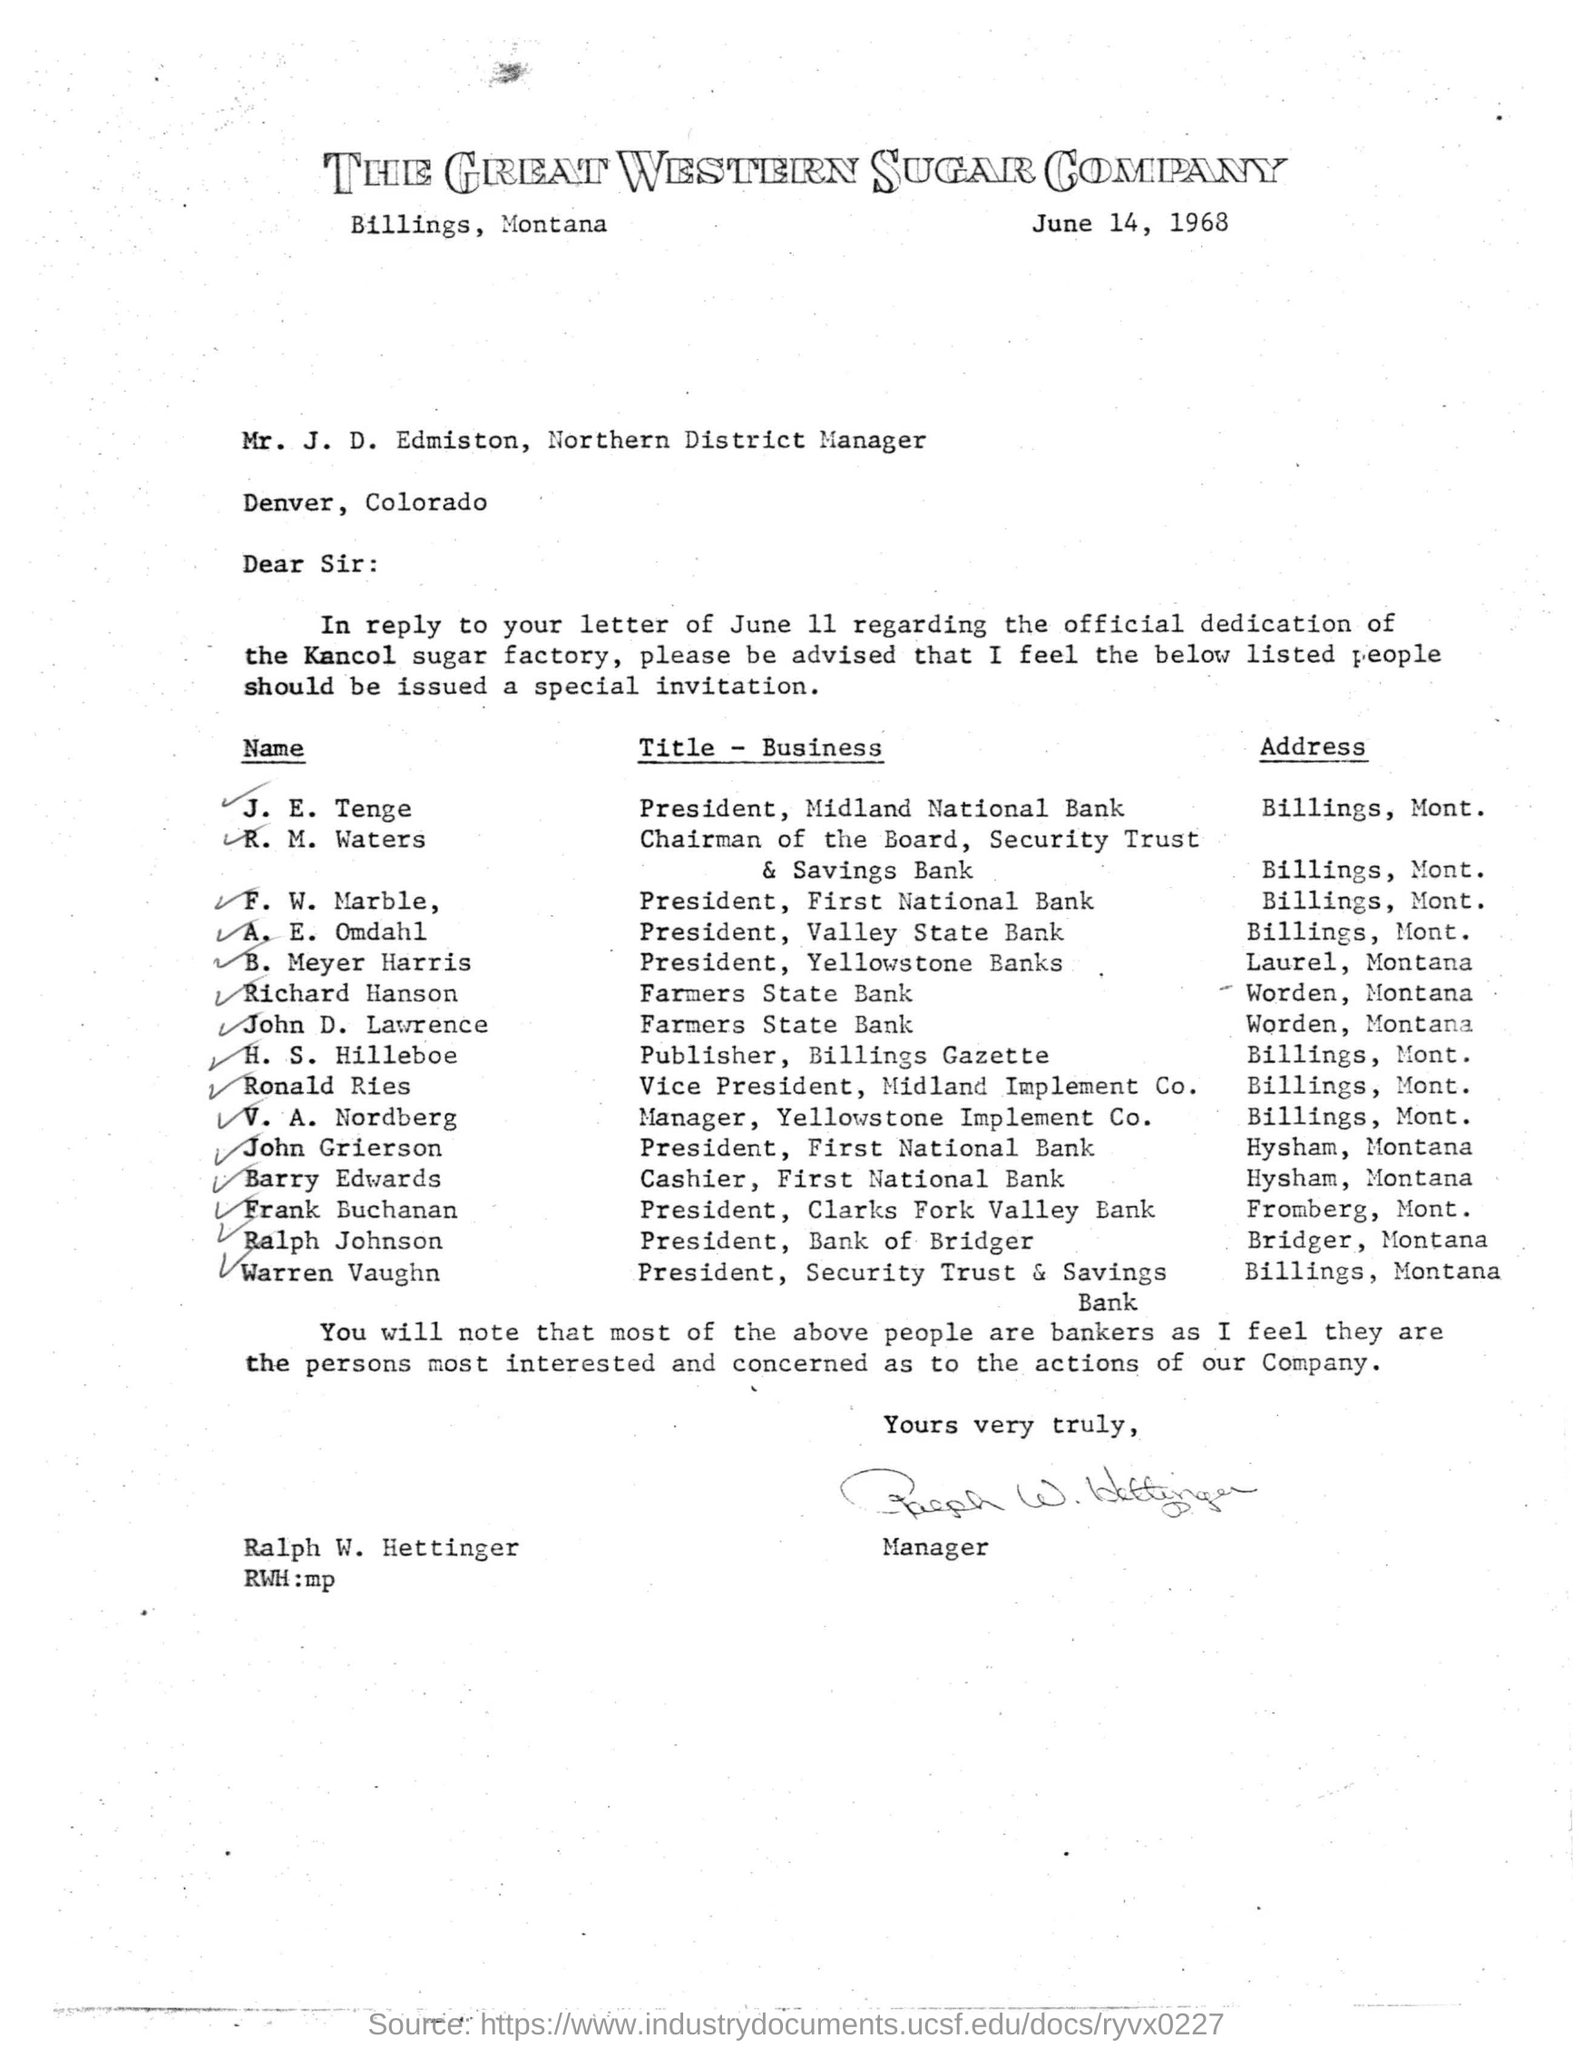What is the designation of Mr.J D Edmiston?
Your answer should be compact. Northern District Manager. Who is F. W. Marble?
Give a very brief answer. President, First National Bank. Who wrote the letter?
Keep it short and to the point. Ralph W. Hettinger. 